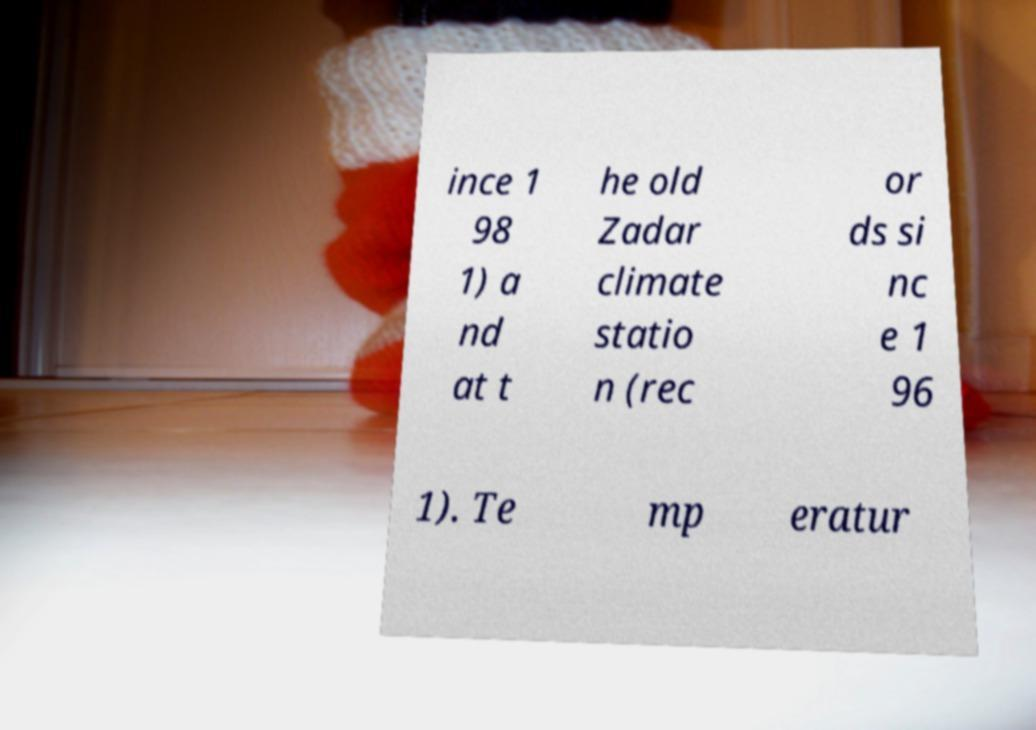Could you extract and type out the text from this image? ince 1 98 1) a nd at t he old Zadar climate statio n (rec or ds si nc e 1 96 1). Te mp eratur 